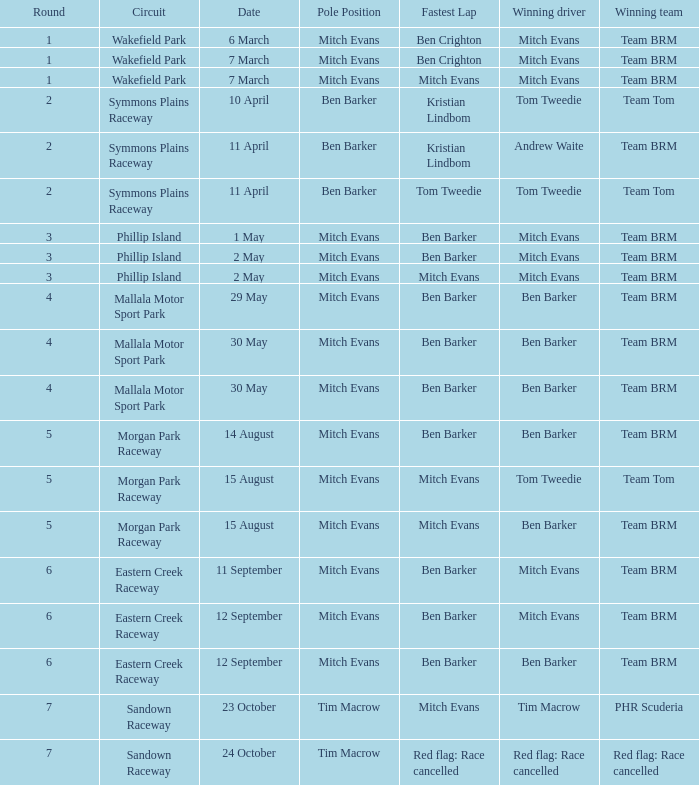In how many rounds was Race 17? 1.0. 